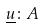Convert formula to latex. <formula><loc_0><loc_0><loc_500><loc_500>\underline { u } \colon A</formula> 